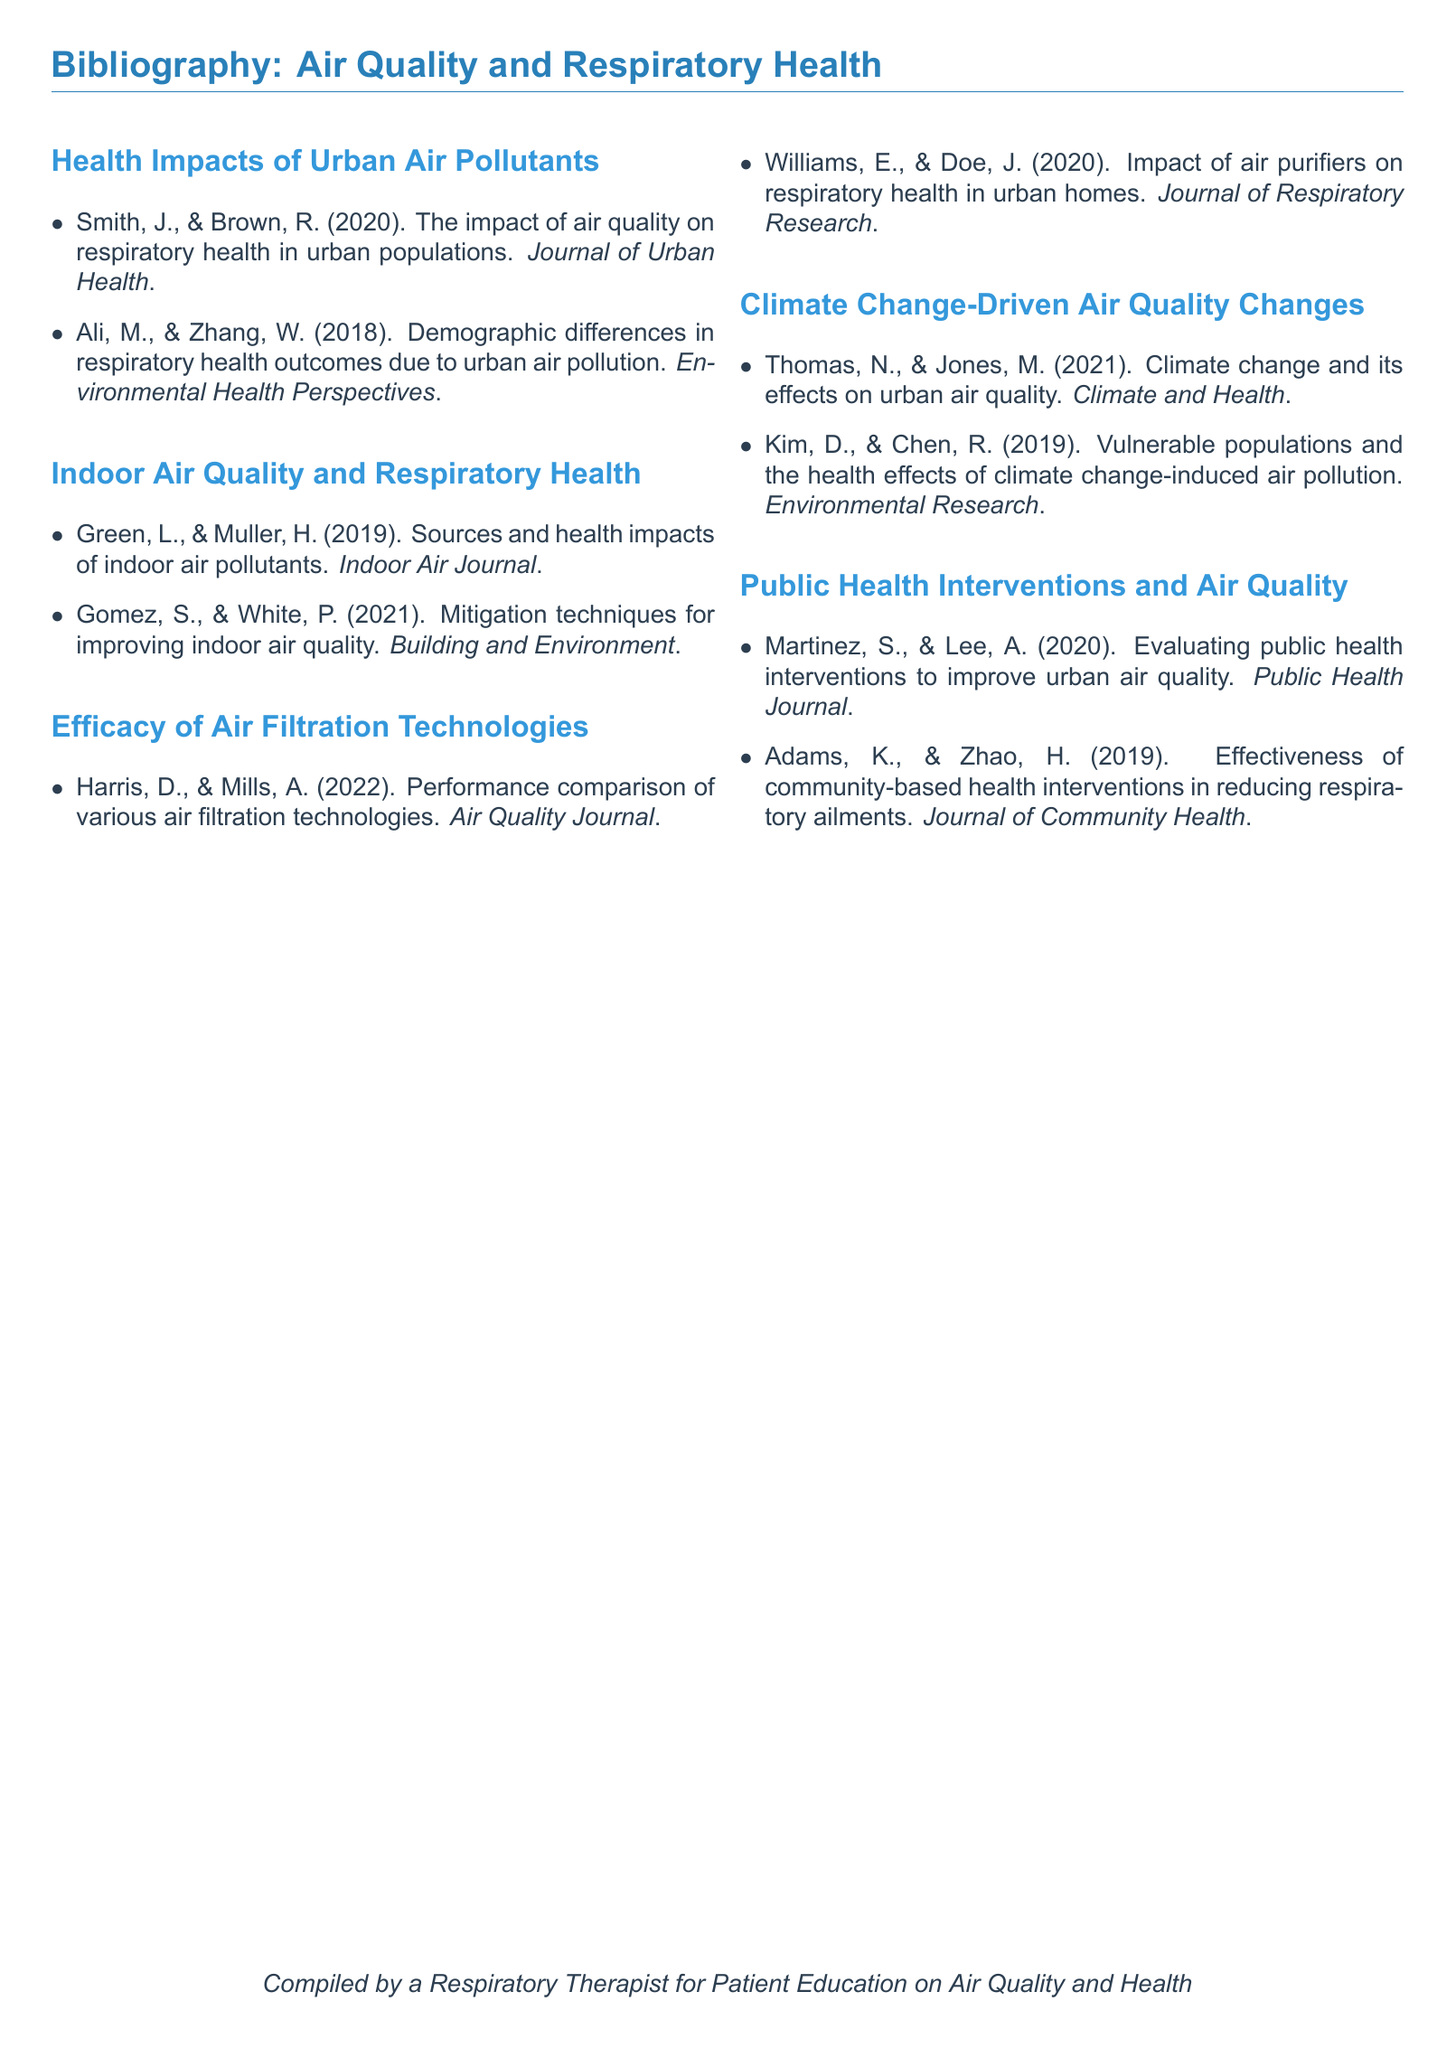What is the title of the first cited study? The title can be found in the first item under the "Health Impacts of Urban Air Pollutants" section.
Answer: The impact of air quality on respiratory health in urban populations Who are the authors of the study on indoor air pollutants? The authors are listed in the second item under the "Indoor Air Quality and Respiratory Health" section.
Answer: Green, L., & Muller, H How many studies are listed under the Efficacy of Air Filtration Technologies? The total number of studies can be counted from the section titled "Efficacy of Air Filtration Technologies."
Answer: 2 Which journal published the study on climate change and urban air quality? The journal name is included at the end of the corresponding study in the "Climate Change-Driven Air Quality Changes" section.
Answer: Climate and Health What year was the study on public health interventions published? The publication date is specified in the first study listed under the "Public Health Interventions and Air Quality" section.
Answer: 2020 What common theme is addressed by the studies in the last two sections? The common theme can be inferred by looking for connections in the respective sections about public health and air quality.
Answer: Respiratory health 